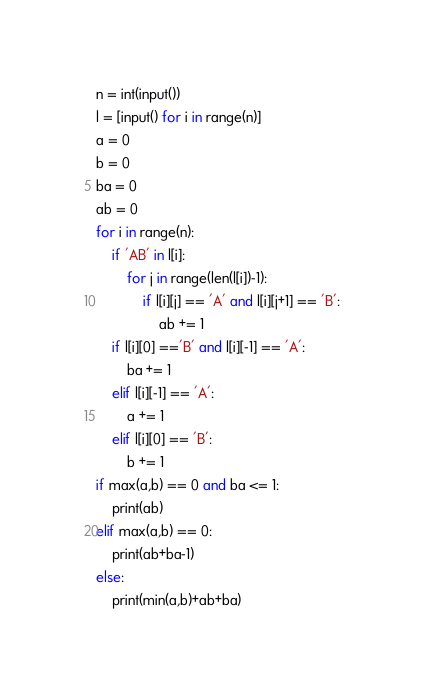<code> <loc_0><loc_0><loc_500><loc_500><_Python_>n = int(input())
l = [input() for i in range(n)]
a = 0
b = 0
ba = 0
ab = 0
for i in range(n):
    if 'AB' in l[i]:
        for j in range(len(l[i])-1):
            if l[i][j] == 'A' and l[i][j+1] == 'B':
                ab += 1
    if l[i][0] =='B' and l[i][-1] == 'A':
        ba += 1
    elif l[i][-1] == 'A':
        a += 1
    elif l[i][0] == 'B':
        b += 1
if max(a,b) == 0 and ba <= 1:
    print(ab)
elif max(a,b) == 0:
    print(ab+ba-1)
else:
    print(min(a,b)+ab+ba)</code> 